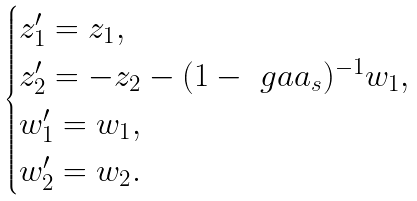Convert formula to latex. <formula><loc_0><loc_0><loc_500><loc_500>\begin{cases} z _ { 1 } ^ { \prime } = z _ { 1 } , \\ z _ { 2 } ^ { \prime } = - z _ { 2 } - ( 1 - \ g a a _ { s } ) ^ { - 1 } w _ { 1 } , \\ w _ { 1 } ^ { \prime } = w _ { 1 } , \\ w _ { 2 } ^ { \prime } = w _ { 2 } . \end{cases}</formula> 